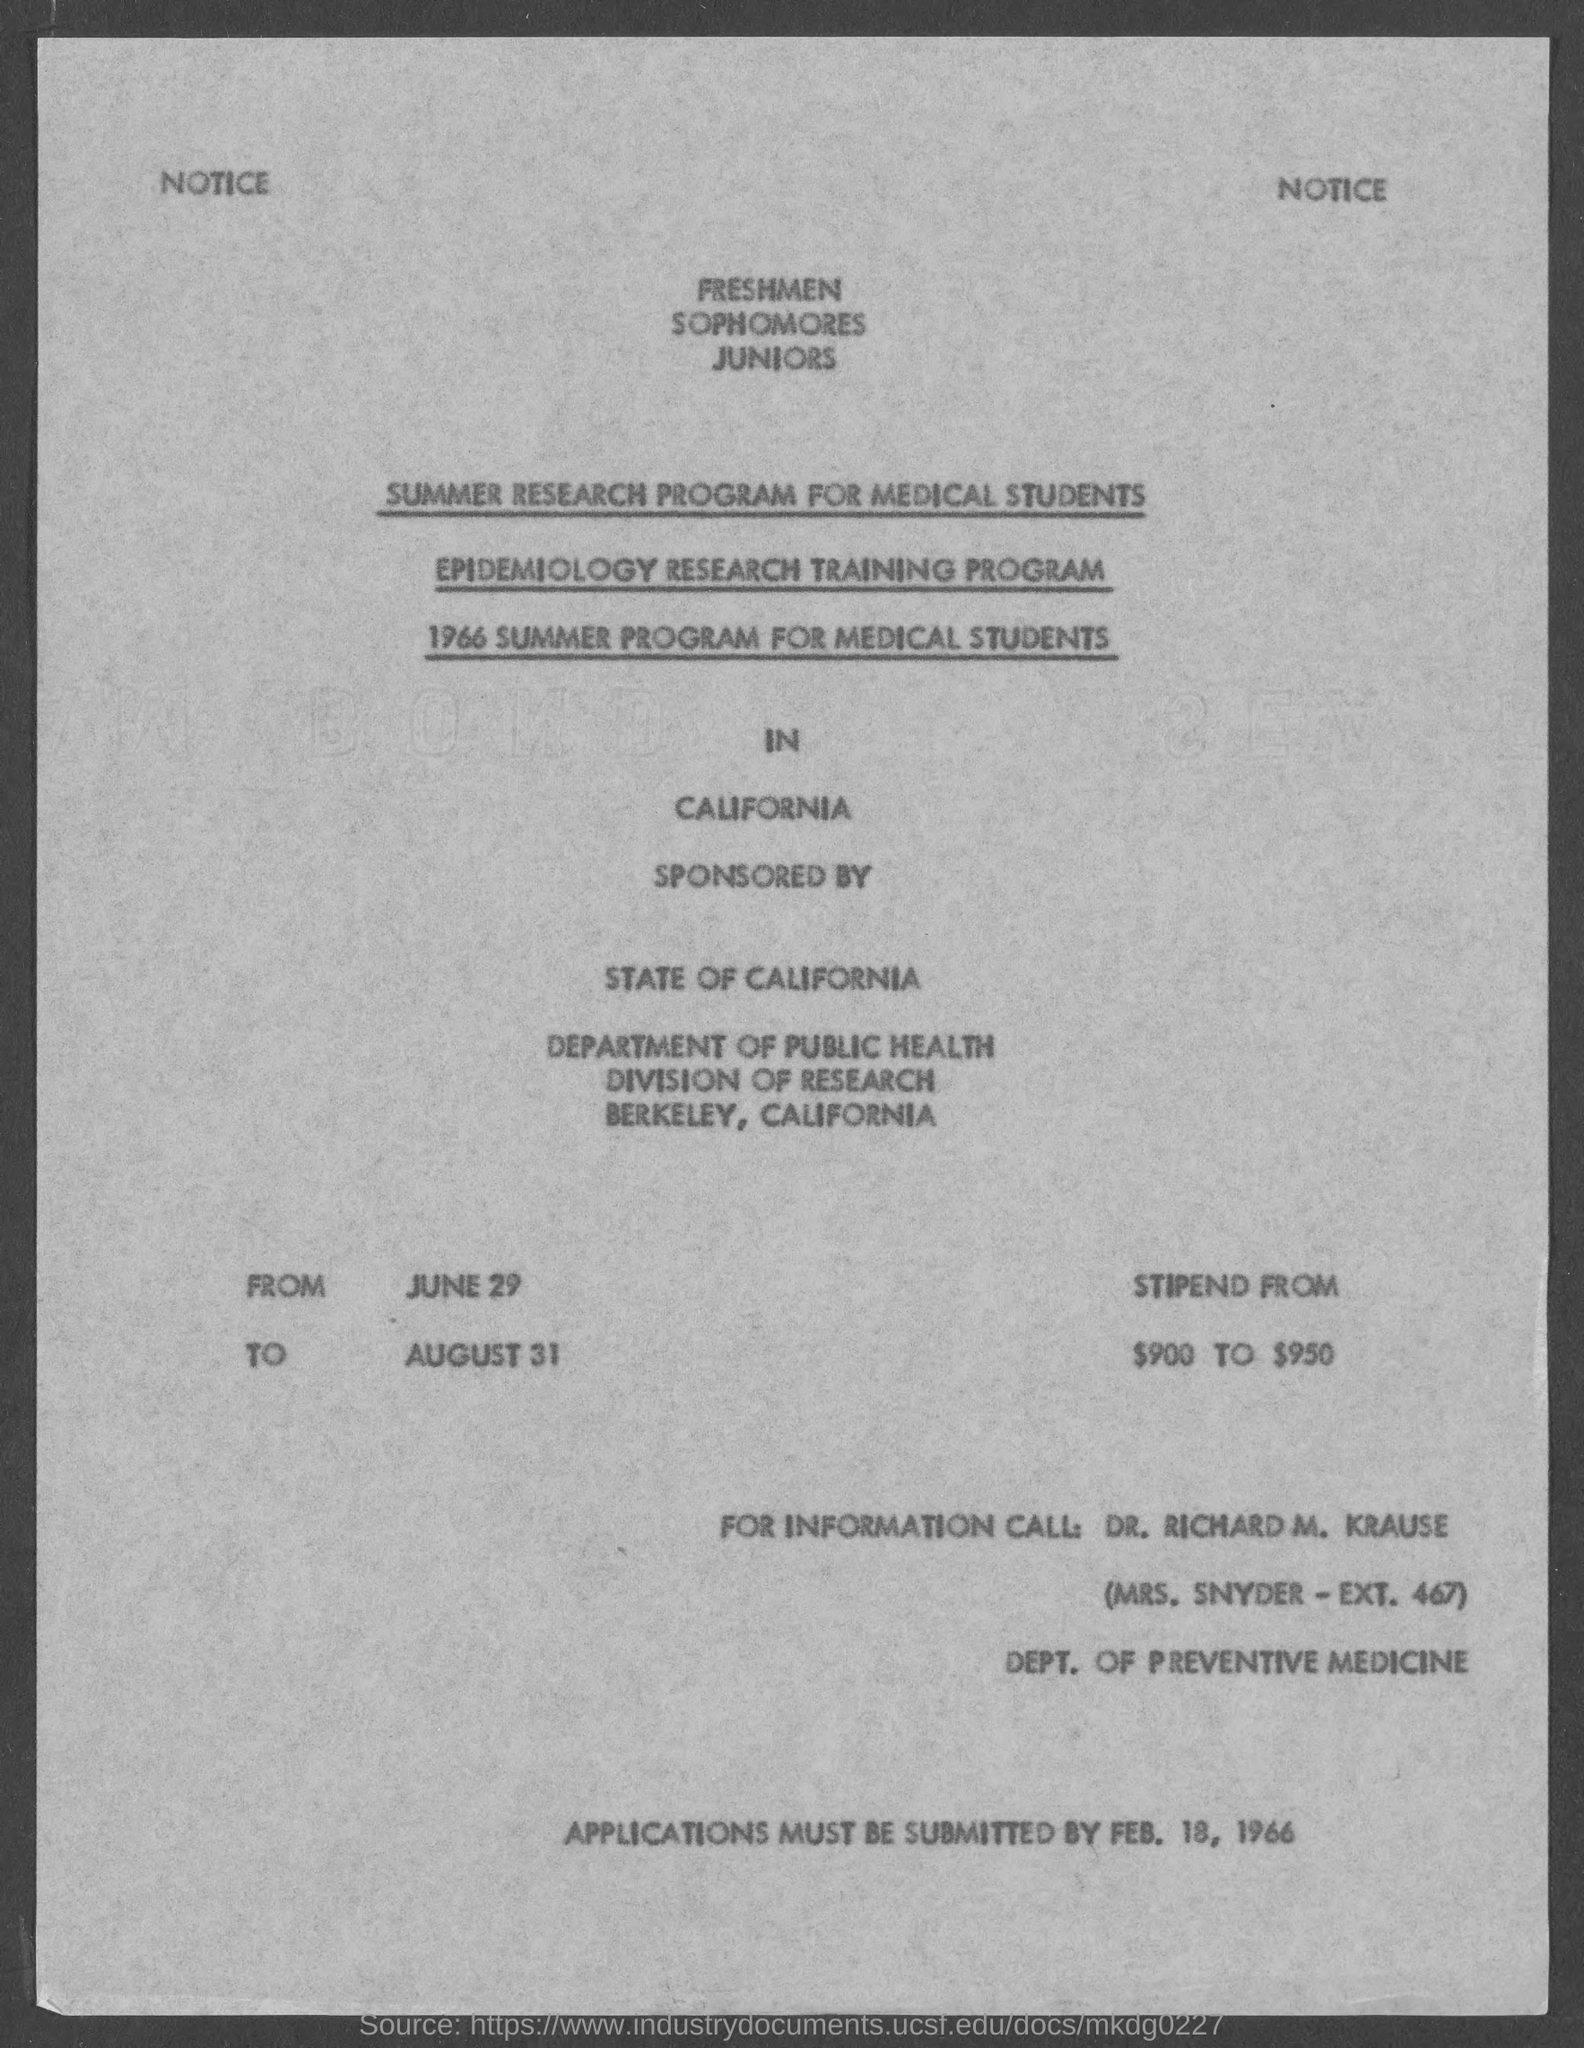Outline some significant characteristics in this image. The stipend ranges from $900 to $950. The program will run until August 31. February 18, 1966 is the deadline for submitting applications. The state of California has sponsored the programs. The program is scheduled to begin on JUNE 29. 